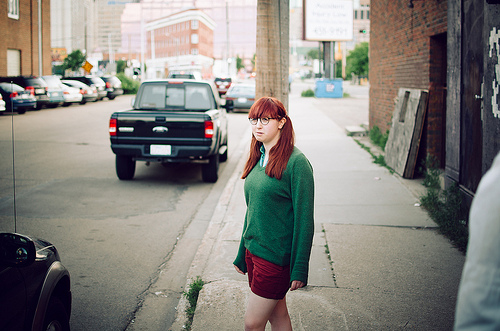<image>
Can you confirm if the girl is to the right of the pickup? Yes. From this viewpoint, the girl is positioned to the right side relative to the pickup. Is the building next to the car? Yes. The building is positioned adjacent to the car, located nearby in the same general area. 